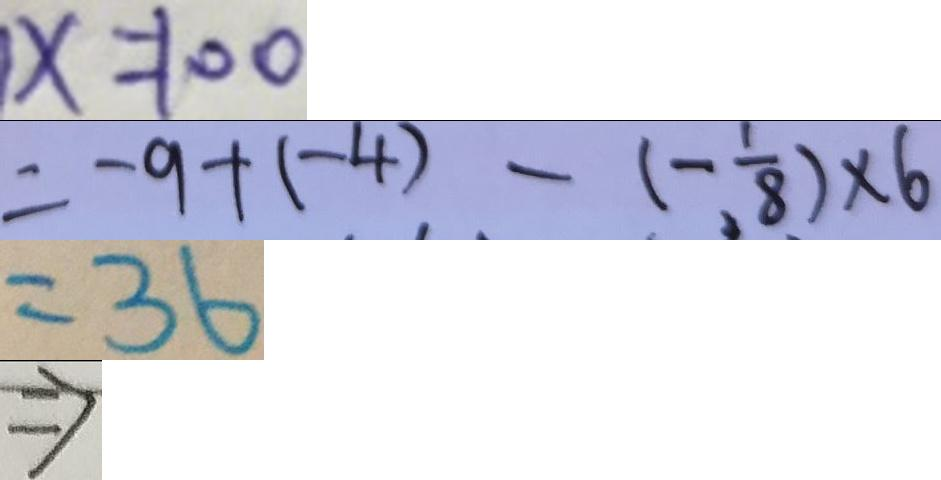<formula> <loc_0><loc_0><loc_500><loc_500>x = 1 0 0 
 = - 9 + ( - 4 ) - ( - \frac { 1 } { 8 } ) \times 6 
 = 3 6 
 \Rightarrow</formula> 